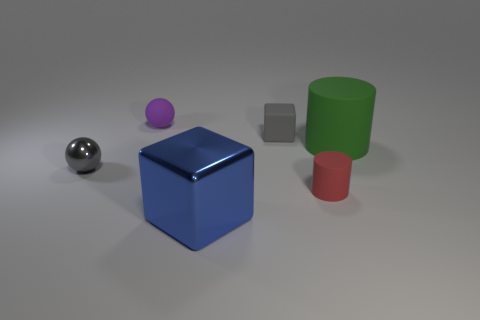Do the metal sphere and the matte block have the same color?
Your response must be concise. Yes. Is there any other thing that is the same color as the tiny block?
Offer a very short reply. Yes. There is a object that is the same color as the small metallic sphere; what is its shape?
Provide a succinct answer. Cube. Do the big thing that is to the left of the gray matte block and the small gray matte object have the same shape?
Your answer should be compact. Yes. Is there another object of the same shape as the small shiny thing?
Your answer should be very brief. Yes. Are any big red rubber things visible?
Give a very brief answer. No. Is the number of tiny metallic balls less than the number of tiny balls?
Give a very brief answer. Yes. Is there a gray cube that has the same size as the purple rubber sphere?
Ensure brevity in your answer.  Yes. Does the gray rubber thing have the same shape as the large thing in front of the tiny metal object?
Ensure brevity in your answer.  Yes. How many cylinders are small gray metal objects or blue shiny things?
Keep it short and to the point. 0. 